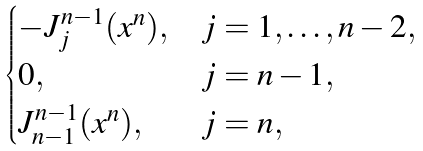<formula> <loc_0><loc_0><loc_500><loc_500>\begin{cases} - J _ { j } ^ { n - 1 } ( x ^ { n } ) , & j = 1 , \dots , n - 2 , \\ 0 , & j = n - 1 , \\ J _ { n - 1 } ^ { n - 1 } ( x ^ { n } ) , & j = n , \end{cases}</formula> 